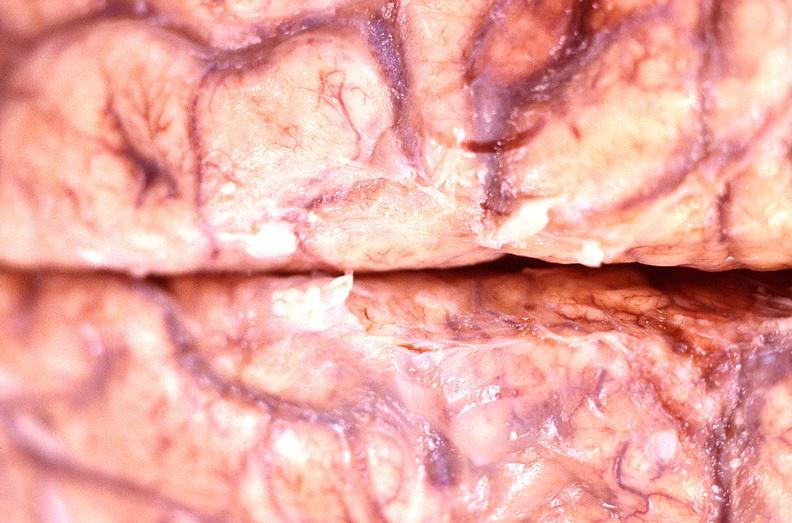does this image show brain abscess?
Answer the question using a single word or phrase. Yes 